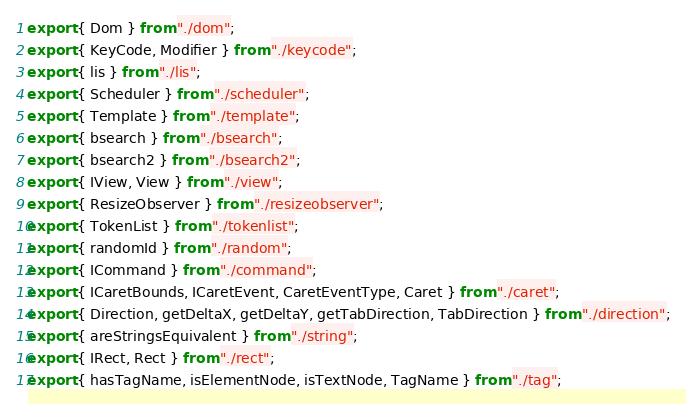Convert code to text. <code><loc_0><loc_0><loc_500><loc_500><_TypeScript_>export { Dom } from "./dom";
export { KeyCode, Modifier } from "./keycode";
export { lis } from "./lis";
export { Scheduler } from "./scheduler";
export { Template } from "./template";
export { bsearch } from "./bsearch";
export { bsearch2 } from "./bsearch2";
export { IView, View } from "./view";
export { ResizeObserver } from "./resizeobserver";
export { TokenList } from "./tokenlist";
export { randomId } from "./random";
export { ICommand } from "./command";
export { ICaretBounds, ICaretEvent, CaretEventType, Caret } from "./caret";
export { Direction, getDeltaX, getDeltaY, getTabDirection, TabDirection } from "./direction";
export { areStringsEquivalent } from "./string";
export { IRect, Rect } from "./rect";
export { hasTagName, isElementNode, isTextNode, TagName } from "./tag";
</code> 